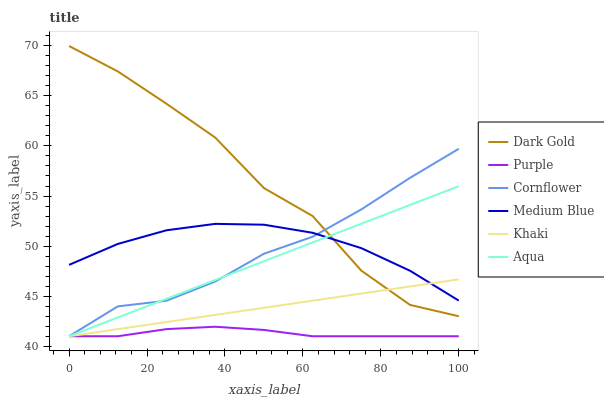Does Purple have the minimum area under the curve?
Answer yes or no. Yes. Does Dark Gold have the maximum area under the curve?
Answer yes or no. Yes. Does Khaki have the minimum area under the curve?
Answer yes or no. No. Does Khaki have the maximum area under the curve?
Answer yes or no. No. Is Khaki the smoothest?
Answer yes or no. Yes. Is Dark Gold the roughest?
Answer yes or no. Yes. Is Dark Gold the smoothest?
Answer yes or no. No. Is Khaki the roughest?
Answer yes or no. No. Does Cornflower have the lowest value?
Answer yes or no. Yes. Does Dark Gold have the lowest value?
Answer yes or no. No. Does Dark Gold have the highest value?
Answer yes or no. Yes. Does Khaki have the highest value?
Answer yes or no. No. Is Purple less than Medium Blue?
Answer yes or no. Yes. Is Dark Gold greater than Purple?
Answer yes or no. Yes. Does Khaki intersect Aqua?
Answer yes or no. Yes. Is Khaki less than Aqua?
Answer yes or no. No. Is Khaki greater than Aqua?
Answer yes or no. No. Does Purple intersect Medium Blue?
Answer yes or no. No. 